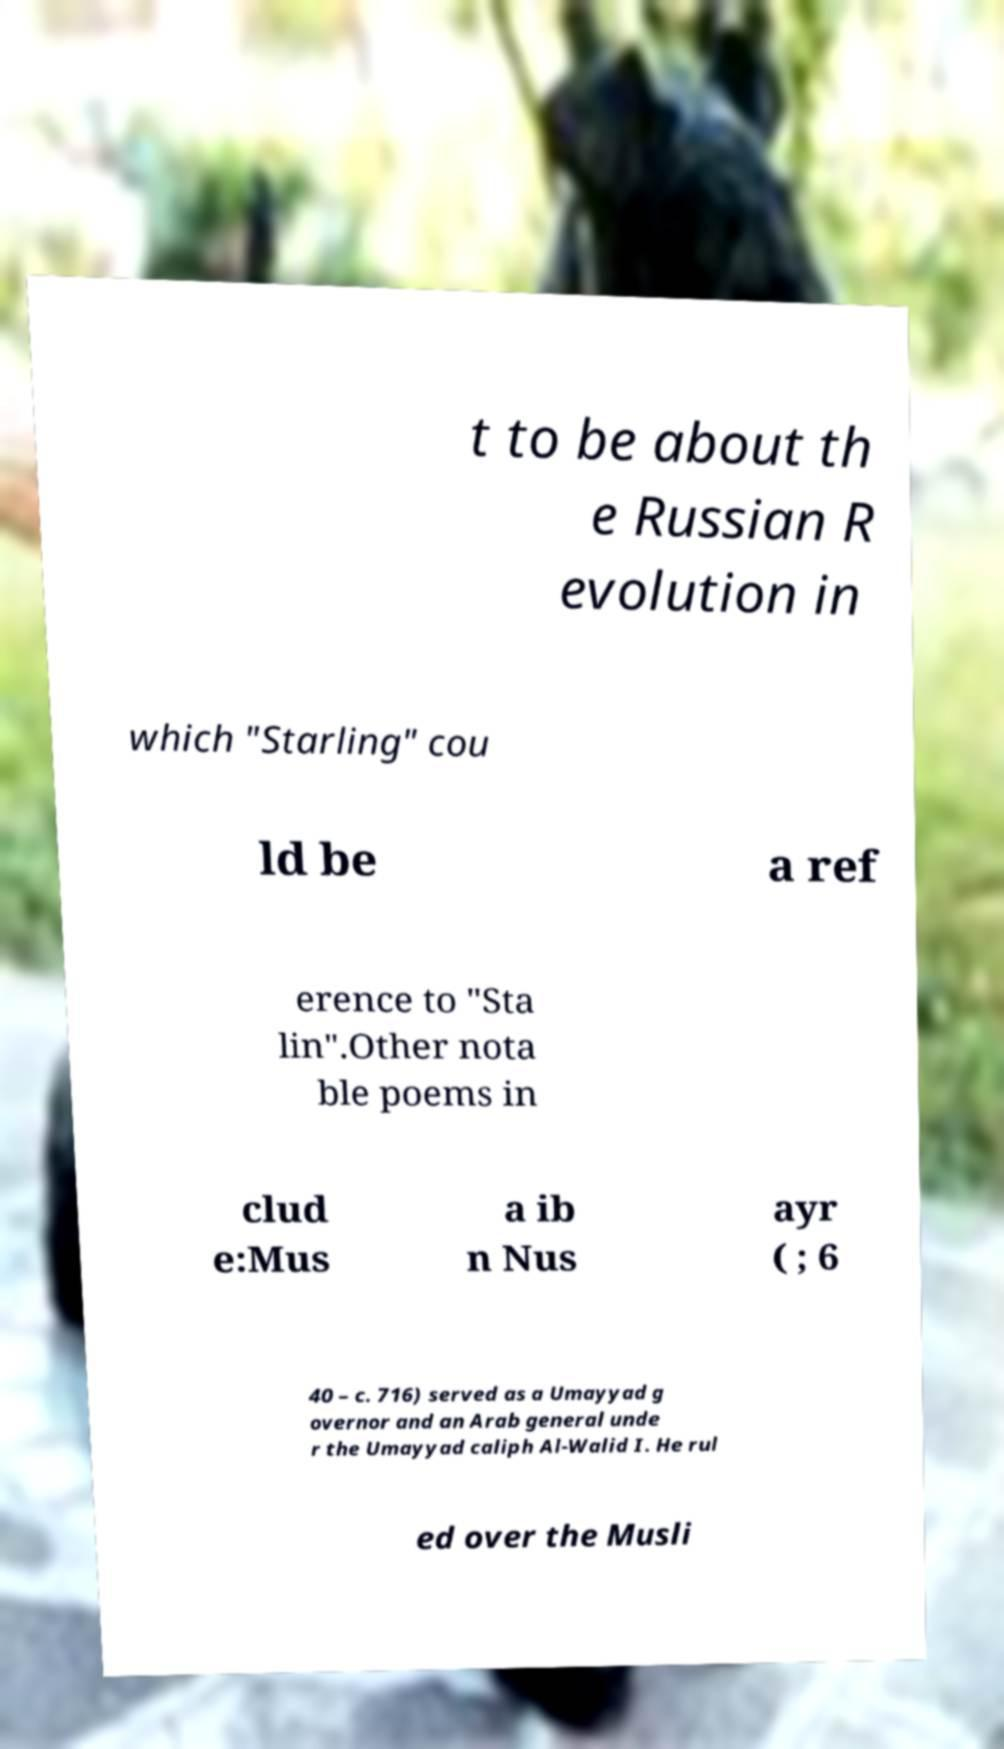I need the written content from this picture converted into text. Can you do that? t to be about th e Russian R evolution in which "Starling" cou ld be a ref erence to "Sta lin".Other nota ble poems in clud e:Mus a ib n Nus ayr ( ; 6 40 – c. 716) served as a Umayyad g overnor and an Arab general unde r the Umayyad caliph Al-Walid I. He rul ed over the Musli 